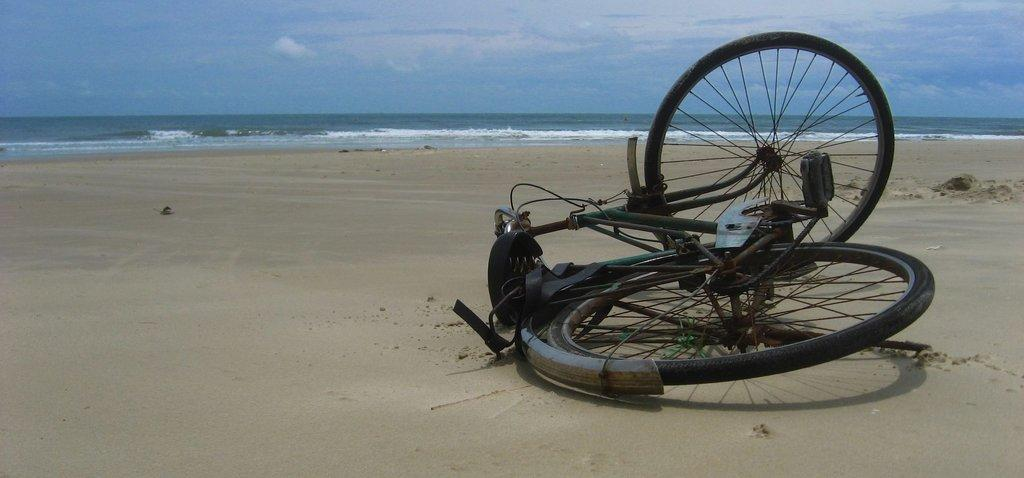What object is on the ground in the image? There is a bicycle on the ground in the image. What can be seen in the background of the image? Water and the sky are visible in the background of the image. What is the condition of the sky in the image? Clouds are present in the sky. How does the carriage twist in the image? There is no carriage present in the image, so it cannot twist. 